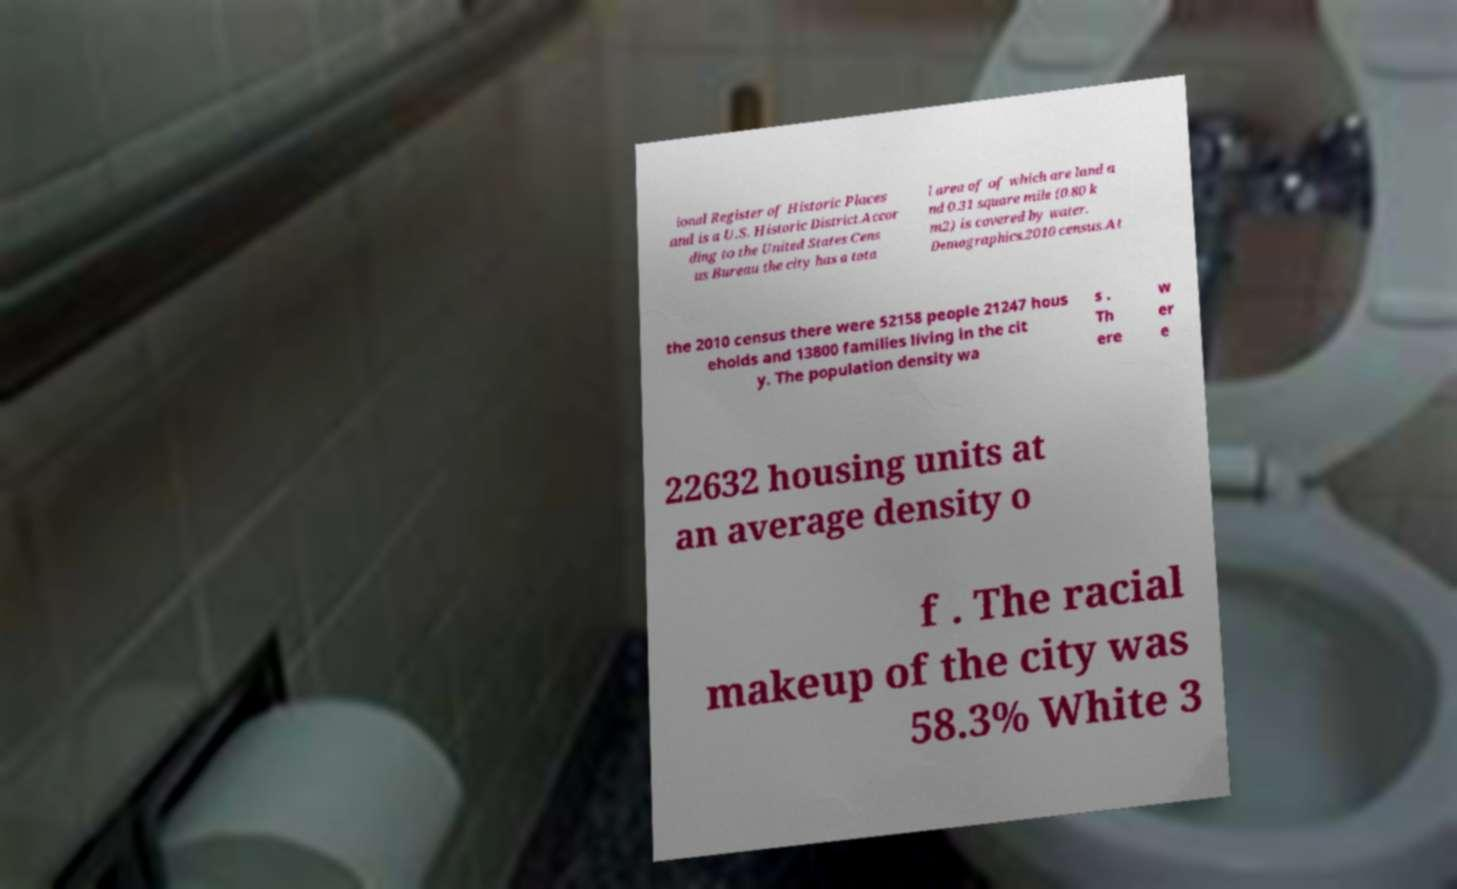For documentation purposes, I need the text within this image transcribed. Could you provide that? ional Register of Historic Places and is a U.S. Historic District.Accor ding to the United States Cens us Bureau the city has a tota l area of of which are land a nd 0.31 square mile (0.80 k m2) is covered by water. Demographics.2010 census.At the 2010 census there were 52158 people 21247 hous eholds and 13800 families living in the cit y. The population density wa s . Th ere w er e 22632 housing units at an average density o f . The racial makeup of the city was 58.3% White 3 